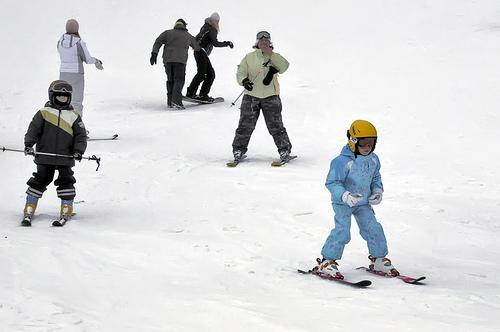What is the likely relationship of the woman to the kids? Please explain your reasoning. mother. The woman is likely the kids' mom. 